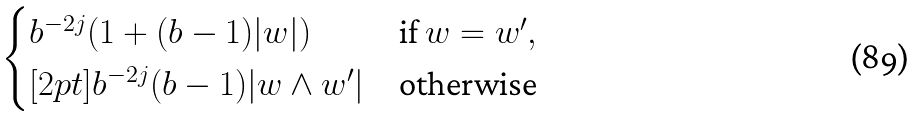Convert formula to latex. <formula><loc_0><loc_0><loc_500><loc_500>\begin{cases} b ^ { - 2 j } ( 1 + ( b - 1 ) | w | ) & \text {if} \ w = w ^ { \prime } , \\ [ 2 p t ] b ^ { - 2 j } ( b - 1 ) | w \land w ^ { \prime } | & \text {otherwise} \end{cases}</formula> 